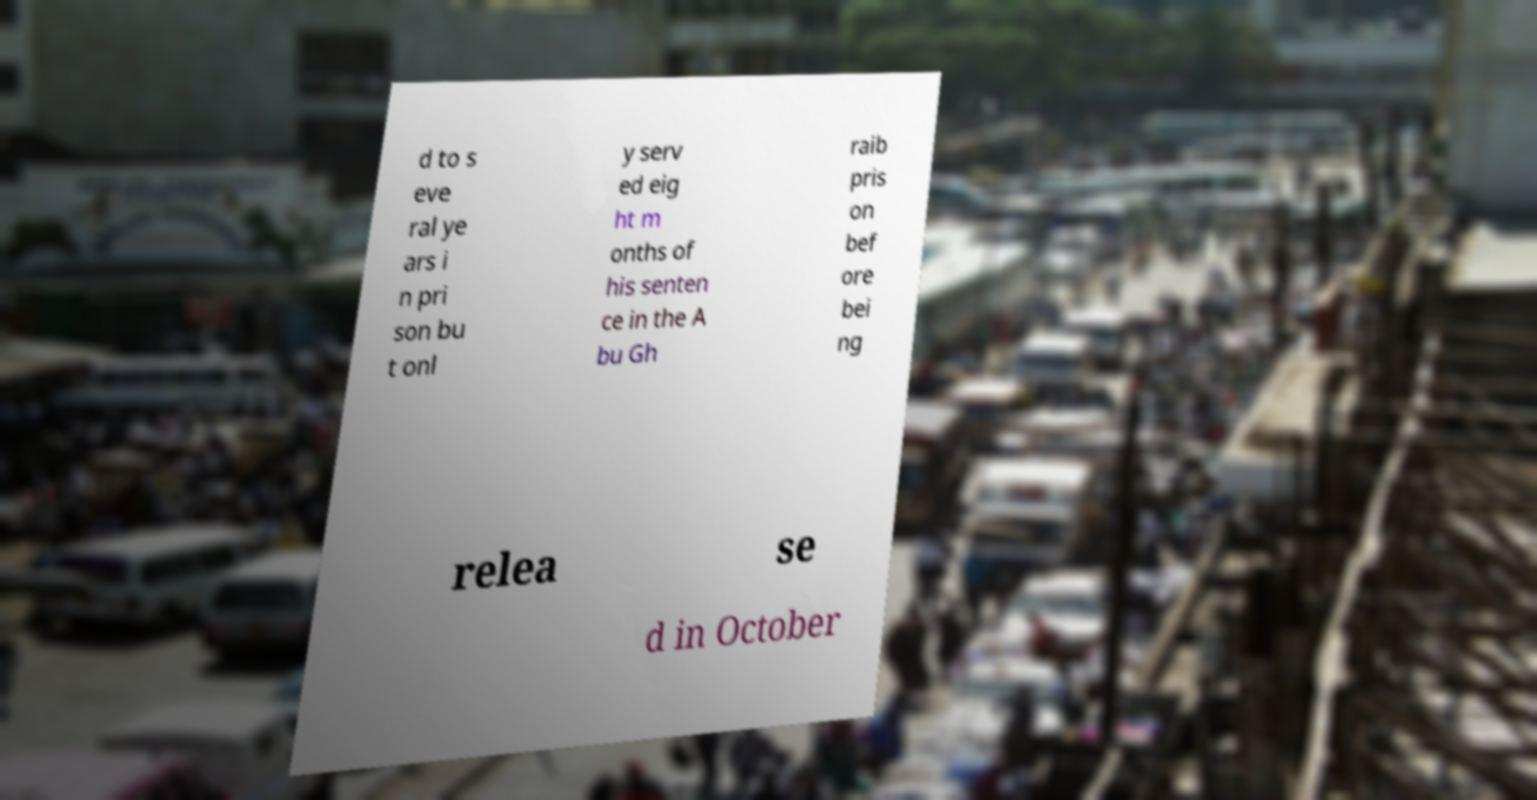For documentation purposes, I need the text within this image transcribed. Could you provide that? d to s eve ral ye ars i n pri son bu t onl y serv ed eig ht m onths of his senten ce in the A bu Gh raib pris on bef ore bei ng relea se d in October 